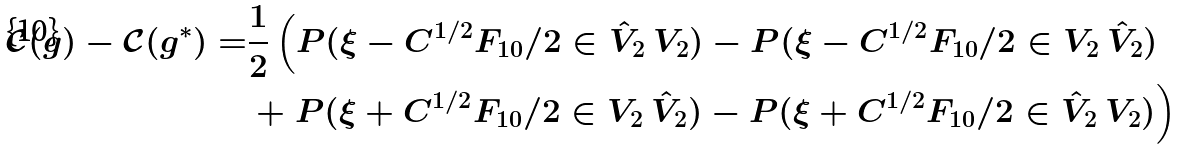Convert formula to latex. <formula><loc_0><loc_0><loc_500><loc_500>\mathcal { C } ( g ) - \mathcal { C } ( g ^ { * } ) = & \frac { 1 } { 2 } \left ( P ( \xi - C ^ { 1 / 2 } F _ { 1 0 } / 2 \in \hat { V } _ { 2 } \ V _ { 2 } ) - P ( \xi - C ^ { 1 / 2 } F _ { 1 0 } / 2 \in V _ { 2 } \ \hat { V } _ { 2 } ) \right . \\ & + \left . P ( \xi + C ^ { 1 / 2 } F _ { 1 0 } / 2 \in V _ { 2 } \ \hat { V } _ { 2 } ) - P ( \xi + C ^ { 1 / 2 } F _ { 1 0 } / 2 \in \hat { V } _ { 2 } \ V _ { 2 } ) \right )</formula> 